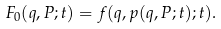Convert formula to latex. <formula><loc_0><loc_0><loc_500><loc_500>F _ { 0 } { \left ( { q } , { P } ; t \right ) } = f { \left ( { q } , { p } { \left ( { q } , { P } ; t \right ) } ; t \right ) } .</formula> 